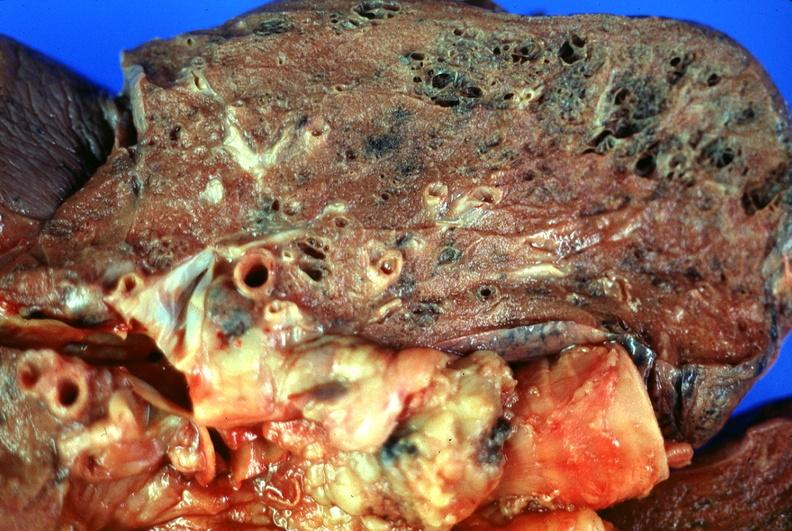what does this image show?
Answer the question using a single word or phrase. Lung 